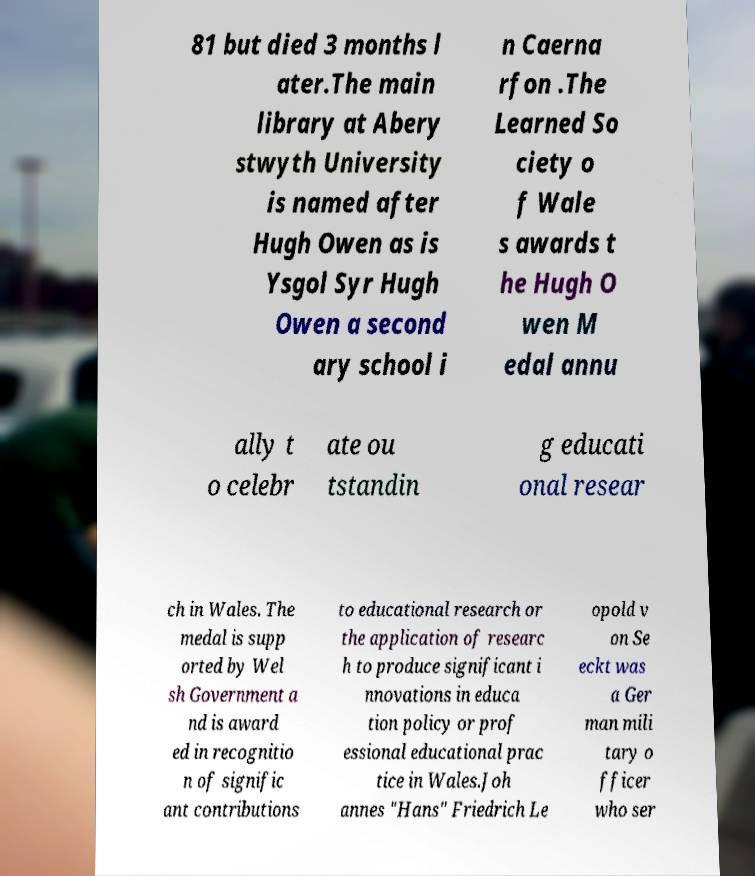Could you assist in decoding the text presented in this image and type it out clearly? 81 but died 3 months l ater.The main library at Abery stwyth University is named after Hugh Owen as is Ysgol Syr Hugh Owen a second ary school i n Caerna rfon .The Learned So ciety o f Wale s awards t he Hugh O wen M edal annu ally t o celebr ate ou tstandin g educati onal resear ch in Wales. The medal is supp orted by Wel sh Government a nd is award ed in recognitio n of signific ant contributions to educational research or the application of researc h to produce significant i nnovations in educa tion policy or prof essional educational prac tice in Wales.Joh annes "Hans" Friedrich Le opold v on Se eckt was a Ger man mili tary o fficer who ser 